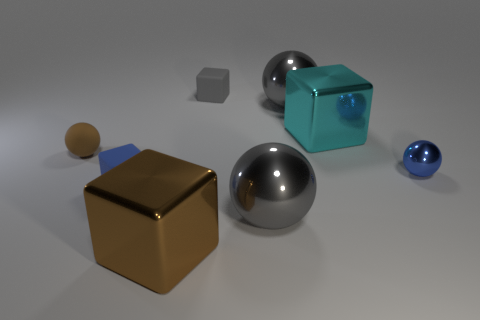Subtract 2 balls. How many balls are left? 2 Subtract all rubber spheres. How many spheres are left? 3 Subtract all blue spheres. How many spheres are left? 3 Add 2 small cyan things. How many objects exist? 10 Subtract all purple blocks. Subtract all green spheres. How many blocks are left? 4 Add 1 blue spheres. How many blue spheres are left? 2 Add 4 big gray shiny balls. How many big gray shiny balls exist? 6 Subtract 1 blue balls. How many objects are left? 7 Subtract all cyan cubes. Subtract all tiny gray rubber objects. How many objects are left? 6 